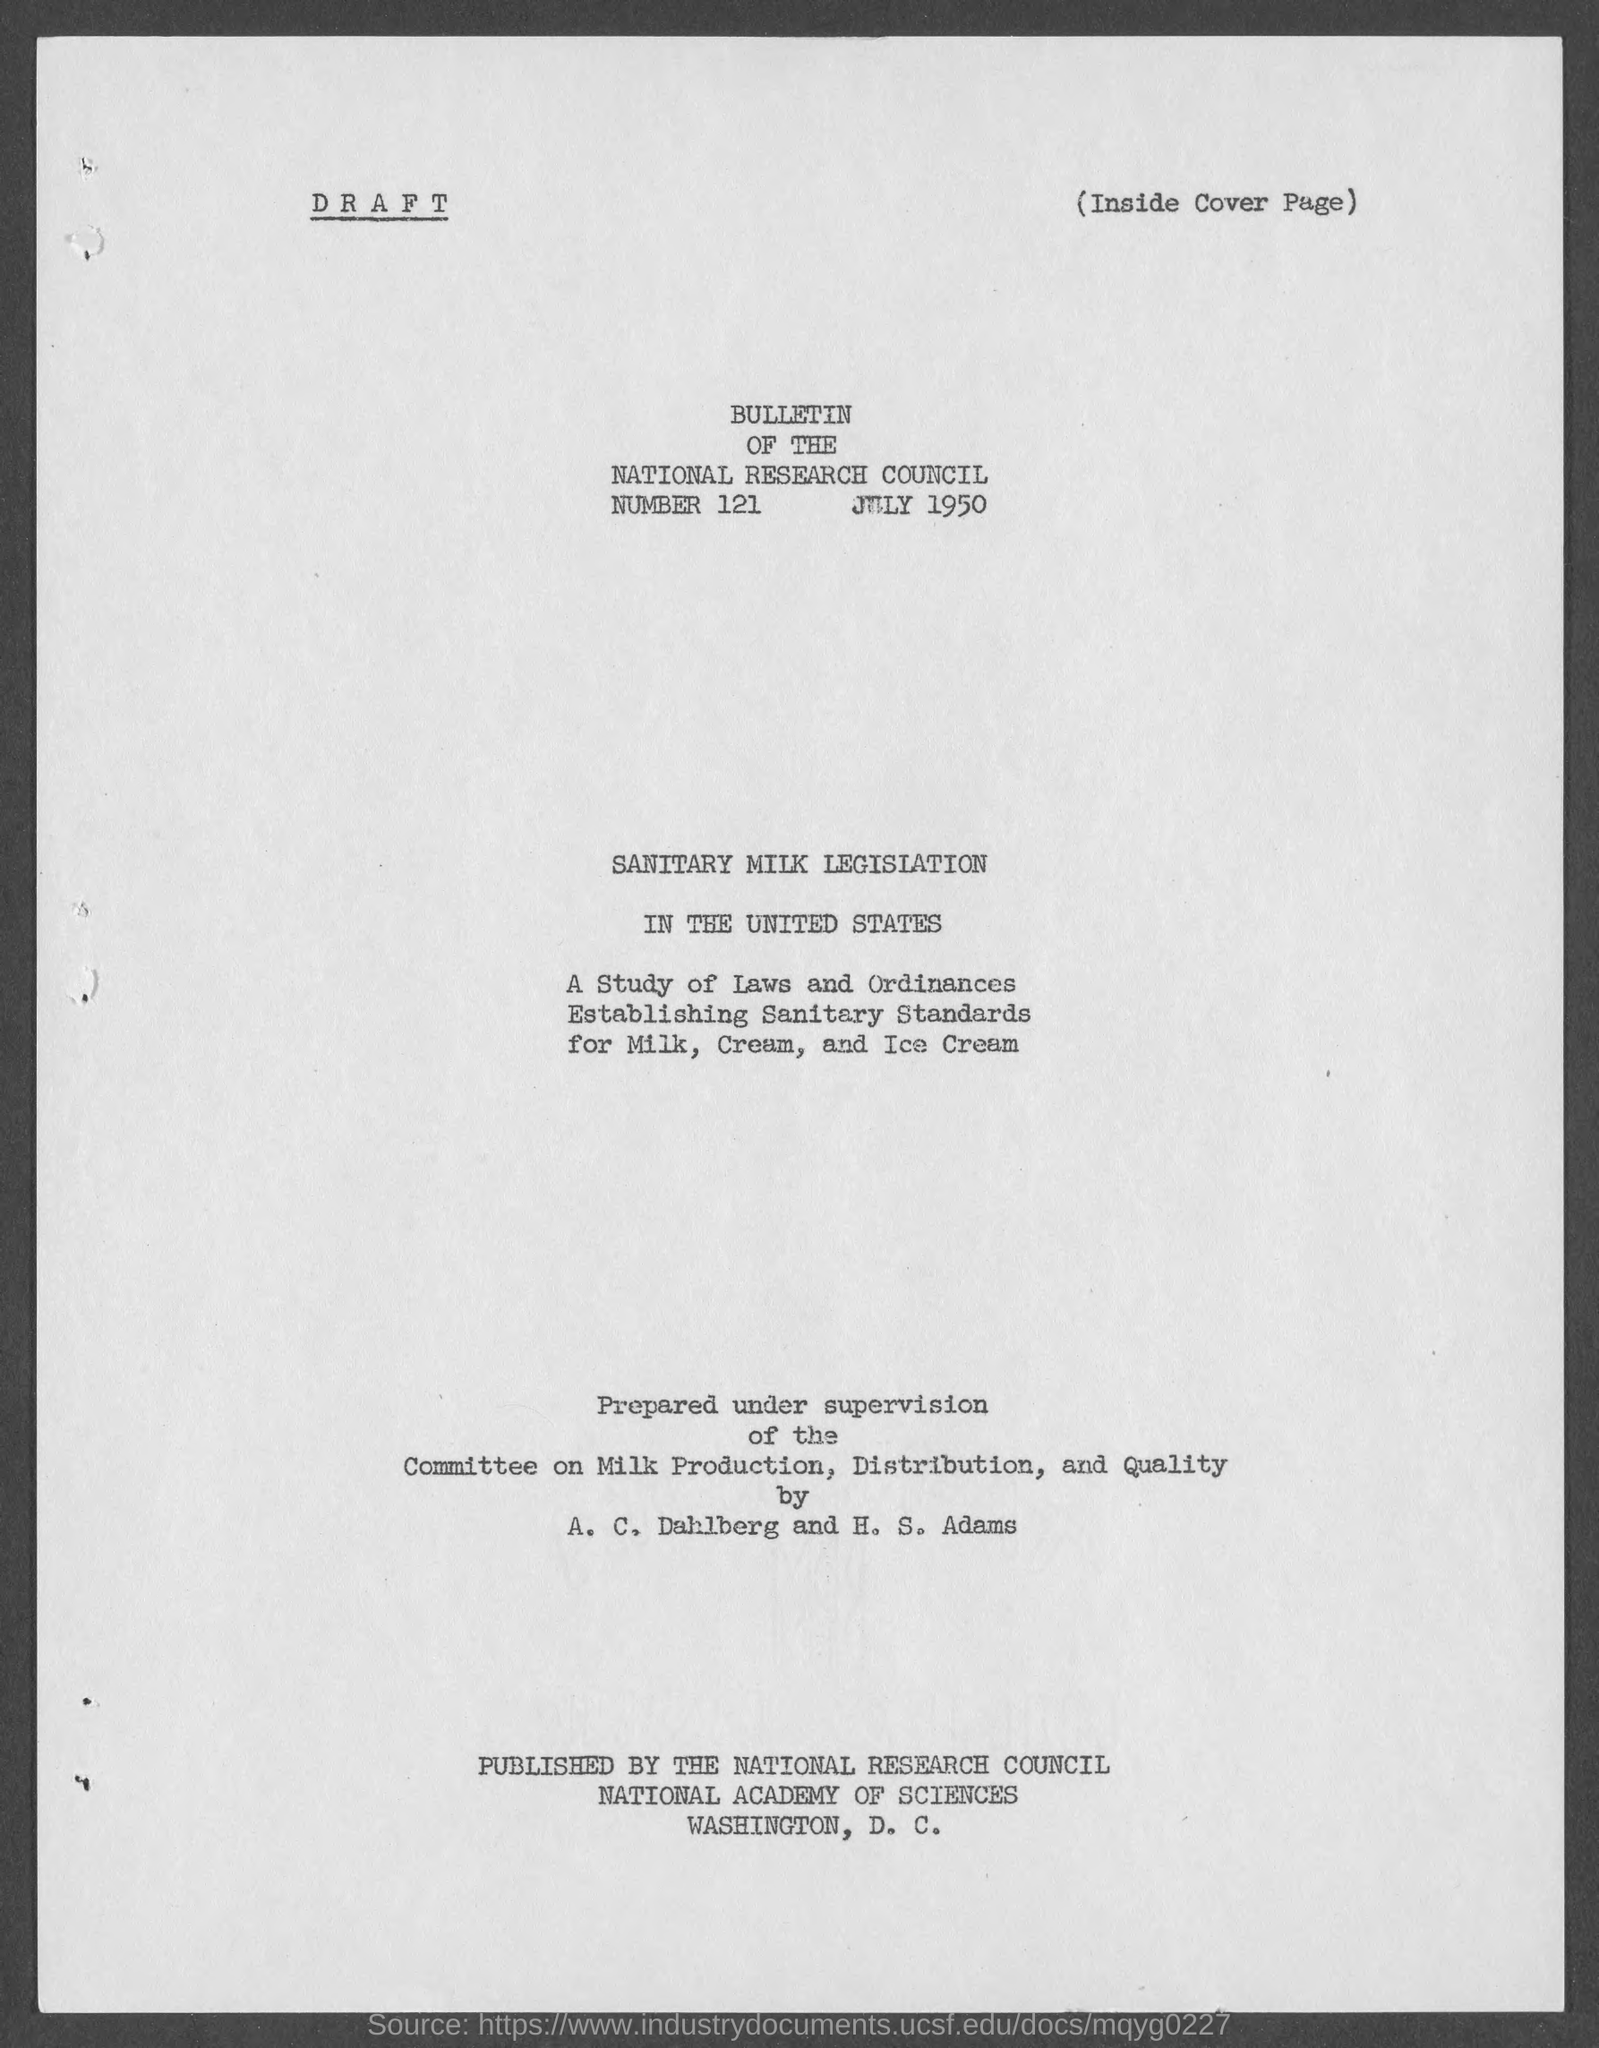What is the date mentioned in the document?
Your answer should be very brief. July 1950. What is the title of the document?
Give a very brief answer. BULLETIN OF THE NATIONAL RESEARCH COUNCIL. 